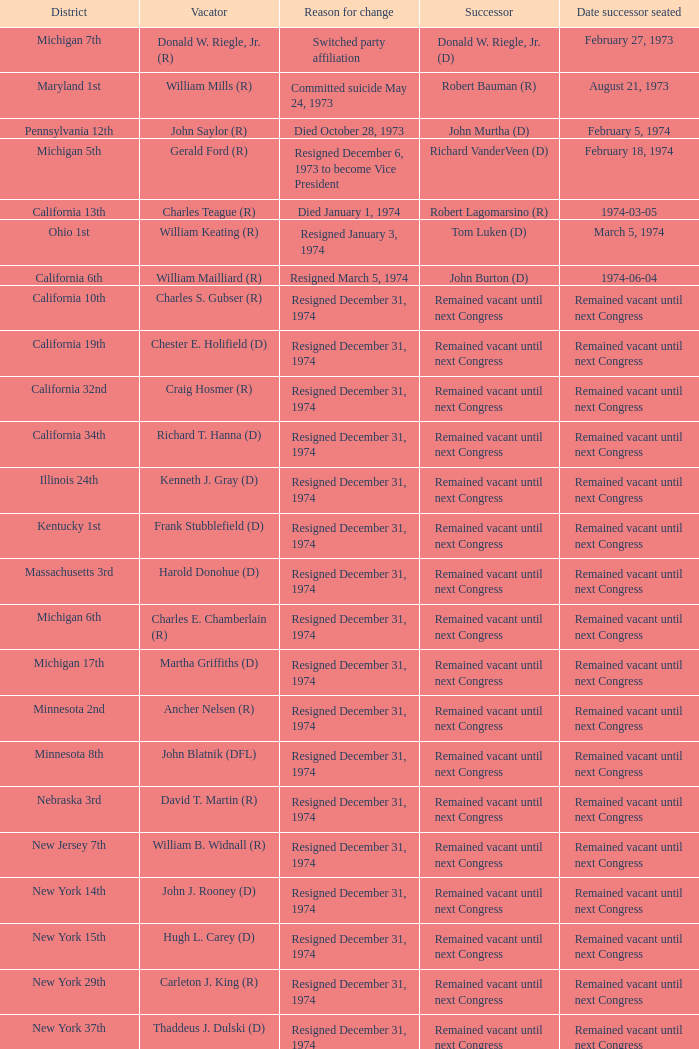When was the date successor seated when the vacator was charles e. chamberlain (r)? Remained vacant until next Congress. 